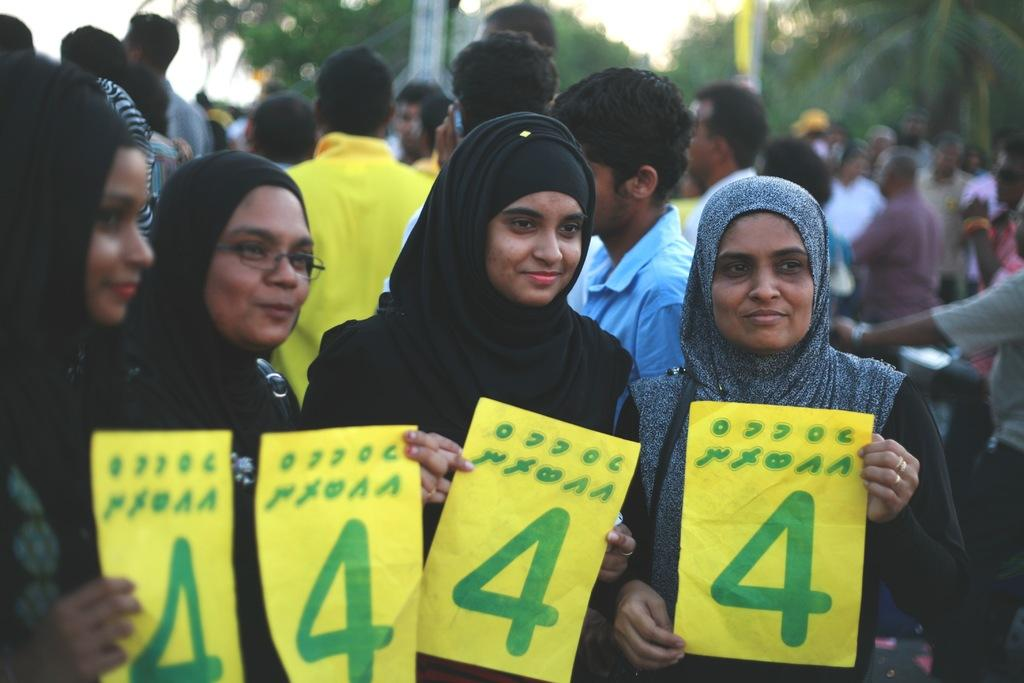Who or what is present in the image? There are people in the image. What are the people holding in their hands? The people are holding papers in their hands. What can be seen in the distance behind the people? There are trees and poles visible in the background, as well as people standing in the background. What color is the star in the image? There is no star present in the image. 